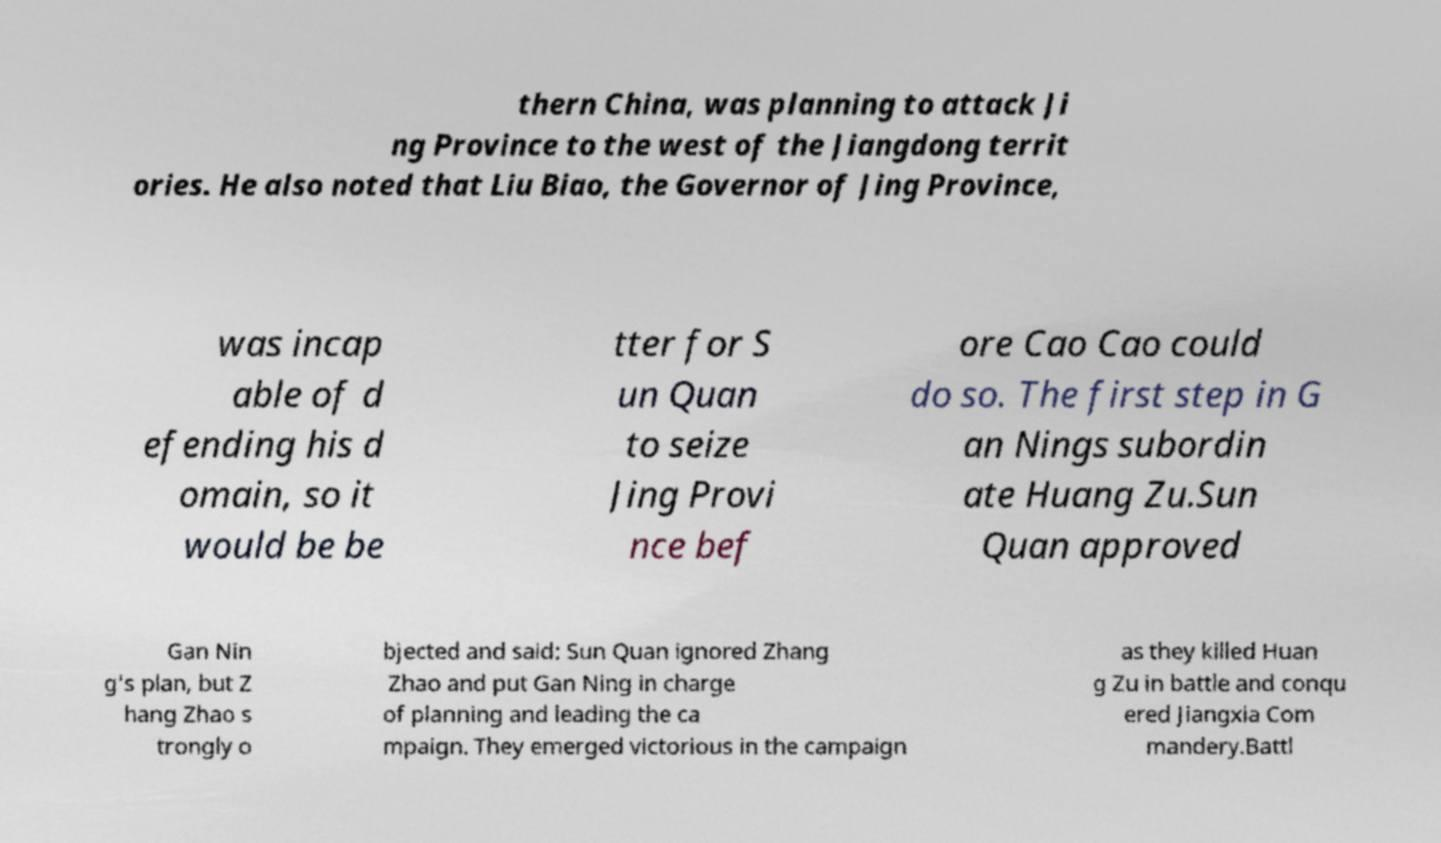Please read and relay the text visible in this image. What does it say? thern China, was planning to attack Ji ng Province to the west of the Jiangdong territ ories. He also noted that Liu Biao, the Governor of Jing Province, was incap able of d efending his d omain, so it would be be tter for S un Quan to seize Jing Provi nce bef ore Cao Cao could do so. The first step in G an Nings subordin ate Huang Zu.Sun Quan approved Gan Nin g's plan, but Z hang Zhao s trongly o bjected and said: Sun Quan ignored Zhang Zhao and put Gan Ning in charge of planning and leading the ca mpaign. They emerged victorious in the campaign as they killed Huan g Zu in battle and conqu ered Jiangxia Com mandery.Battl 